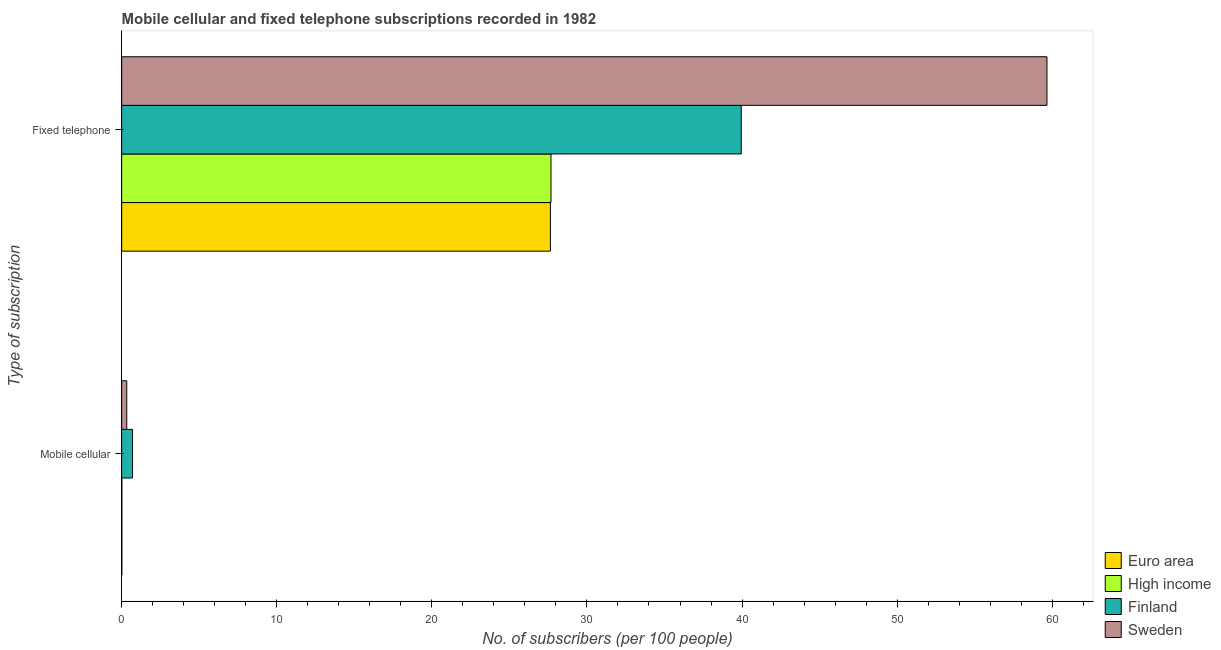How many different coloured bars are there?
Offer a terse response. 4. How many groups of bars are there?
Keep it short and to the point. 2. Are the number of bars per tick equal to the number of legend labels?
Your answer should be compact. Yes. How many bars are there on the 1st tick from the top?
Keep it short and to the point. 4. What is the label of the 2nd group of bars from the top?
Make the answer very short. Mobile cellular. What is the number of fixed telephone subscribers in Sweden?
Keep it short and to the point. 59.66. Across all countries, what is the maximum number of mobile cellular subscribers?
Make the answer very short. 0.7. Across all countries, what is the minimum number of fixed telephone subscribers?
Provide a succinct answer. 27.64. In which country was the number of fixed telephone subscribers maximum?
Your response must be concise. Sweden. What is the total number of mobile cellular subscribers in the graph?
Offer a very short reply. 1.05. What is the difference between the number of fixed telephone subscribers in Sweden and that in High income?
Your response must be concise. 31.98. What is the difference between the number of mobile cellular subscribers in Sweden and the number of fixed telephone subscribers in Euro area?
Make the answer very short. -27.32. What is the average number of mobile cellular subscribers per country?
Give a very brief answer. 0.26. What is the difference between the number of mobile cellular subscribers and number of fixed telephone subscribers in Euro area?
Make the answer very short. -27.63. What is the ratio of the number of fixed telephone subscribers in High income to that in Euro area?
Keep it short and to the point. 1. What does the 4th bar from the bottom in Mobile cellular represents?
Your response must be concise. Sweden. Are all the bars in the graph horizontal?
Your answer should be compact. Yes. How many countries are there in the graph?
Offer a terse response. 4. What is the difference between two consecutive major ticks on the X-axis?
Offer a terse response. 10. Are the values on the major ticks of X-axis written in scientific E-notation?
Ensure brevity in your answer.  No. Does the graph contain grids?
Ensure brevity in your answer.  No. How many legend labels are there?
Your answer should be compact. 4. What is the title of the graph?
Provide a succinct answer. Mobile cellular and fixed telephone subscriptions recorded in 1982. What is the label or title of the X-axis?
Make the answer very short. No. of subscribers (per 100 people). What is the label or title of the Y-axis?
Your answer should be compact. Type of subscription. What is the No. of subscribers (per 100 people) in Euro area in Mobile cellular?
Offer a very short reply. 0.01. What is the No. of subscribers (per 100 people) of High income in Mobile cellular?
Your answer should be very brief. 0.01. What is the No. of subscribers (per 100 people) of Finland in Mobile cellular?
Make the answer very short. 0.7. What is the No. of subscribers (per 100 people) of Sweden in Mobile cellular?
Your answer should be very brief. 0.33. What is the No. of subscribers (per 100 people) in Euro area in Fixed telephone?
Your response must be concise. 27.64. What is the No. of subscribers (per 100 people) of High income in Fixed telephone?
Keep it short and to the point. 27.68. What is the No. of subscribers (per 100 people) in Finland in Fixed telephone?
Provide a short and direct response. 39.95. What is the No. of subscribers (per 100 people) of Sweden in Fixed telephone?
Your response must be concise. 59.66. Across all Type of subscription, what is the maximum No. of subscribers (per 100 people) of Euro area?
Provide a short and direct response. 27.64. Across all Type of subscription, what is the maximum No. of subscribers (per 100 people) of High income?
Your answer should be compact. 27.68. Across all Type of subscription, what is the maximum No. of subscribers (per 100 people) of Finland?
Provide a short and direct response. 39.95. Across all Type of subscription, what is the maximum No. of subscribers (per 100 people) of Sweden?
Make the answer very short. 59.66. Across all Type of subscription, what is the minimum No. of subscribers (per 100 people) in Euro area?
Ensure brevity in your answer.  0.01. Across all Type of subscription, what is the minimum No. of subscribers (per 100 people) in High income?
Offer a very short reply. 0.01. Across all Type of subscription, what is the minimum No. of subscribers (per 100 people) of Finland?
Provide a succinct answer. 0.7. Across all Type of subscription, what is the minimum No. of subscribers (per 100 people) of Sweden?
Offer a terse response. 0.33. What is the total No. of subscribers (per 100 people) of Euro area in the graph?
Make the answer very short. 27.66. What is the total No. of subscribers (per 100 people) of High income in the graph?
Your answer should be very brief. 27.69. What is the total No. of subscribers (per 100 people) of Finland in the graph?
Offer a very short reply. 40.65. What is the total No. of subscribers (per 100 people) in Sweden in the graph?
Keep it short and to the point. 59.99. What is the difference between the No. of subscribers (per 100 people) of Euro area in Mobile cellular and that in Fixed telephone?
Offer a terse response. -27.63. What is the difference between the No. of subscribers (per 100 people) of High income in Mobile cellular and that in Fixed telephone?
Offer a terse response. -27.67. What is the difference between the No. of subscribers (per 100 people) in Finland in Mobile cellular and that in Fixed telephone?
Your answer should be compact. -39.25. What is the difference between the No. of subscribers (per 100 people) of Sweden in Mobile cellular and that in Fixed telephone?
Provide a succinct answer. -59.33. What is the difference between the No. of subscribers (per 100 people) in Euro area in Mobile cellular and the No. of subscribers (per 100 people) in High income in Fixed telephone?
Provide a short and direct response. -27.67. What is the difference between the No. of subscribers (per 100 people) of Euro area in Mobile cellular and the No. of subscribers (per 100 people) of Finland in Fixed telephone?
Your response must be concise. -39.94. What is the difference between the No. of subscribers (per 100 people) in Euro area in Mobile cellular and the No. of subscribers (per 100 people) in Sweden in Fixed telephone?
Give a very brief answer. -59.65. What is the difference between the No. of subscribers (per 100 people) in High income in Mobile cellular and the No. of subscribers (per 100 people) in Finland in Fixed telephone?
Your answer should be compact. -39.94. What is the difference between the No. of subscribers (per 100 people) in High income in Mobile cellular and the No. of subscribers (per 100 people) in Sweden in Fixed telephone?
Provide a succinct answer. -59.65. What is the difference between the No. of subscribers (per 100 people) of Finland in Mobile cellular and the No. of subscribers (per 100 people) of Sweden in Fixed telephone?
Offer a very short reply. -58.96. What is the average No. of subscribers (per 100 people) of Euro area per Type of subscription?
Your answer should be very brief. 13.83. What is the average No. of subscribers (per 100 people) in High income per Type of subscription?
Ensure brevity in your answer.  13.85. What is the average No. of subscribers (per 100 people) of Finland per Type of subscription?
Offer a terse response. 20.33. What is the average No. of subscribers (per 100 people) in Sweden per Type of subscription?
Ensure brevity in your answer.  29.99. What is the difference between the No. of subscribers (per 100 people) of Euro area and No. of subscribers (per 100 people) of High income in Mobile cellular?
Provide a succinct answer. -0. What is the difference between the No. of subscribers (per 100 people) in Euro area and No. of subscribers (per 100 people) in Finland in Mobile cellular?
Your response must be concise. -0.69. What is the difference between the No. of subscribers (per 100 people) of Euro area and No. of subscribers (per 100 people) of Sweden in Mobile cellular?
Provide a succinct answer. -0.32. What is the difference between the No. of subscribers (per 100 people) in High income and No. of subscribers (per 100 people) in Finland in Mobile cellular?
Keep it short and to the point. -0.69. What is the difference between the No. of subscribers (per 100 people) in High income and No. of subscribers (per 100 people) in Sweden in Mobile cellular?
Make the answer very short. -0.32. What is the difference between the No. of subscribers (per 100 people) of Finland and No. of subscribers (per 100 people) of Sweden in Mobile cellular?
Give a very brief answer. 0.37. What is the difference between the No. of subscribers (per 100 people) in Euro area and No. of subscribers (per 100 people) in High income in Fixed telephone?
Provide a succinct answer. -0.04. What is the difference between the No. of subscribers (per 100 people) in Euro area and No. of subscribers (per 100 people) in Finland in Fixed telephone?
Offer a very short reply. -12.3. What is the difference between the No. of subscribers (per 100 people) in Euro area and No. of subscribers (per 100 people) in Sweden in Fixed telephone?
Your answer should be very brief. -32.02. What is the difference between the No. of subscribers (per 100 people) of High income and No. of subscribers (per 100 people) of Finland in Fixed telephone?
Make the answer very short. -12.27. What is the difference between the No. of subscribers (per 100 people) of High income and No. of subscribers (per 100 people) of Sweden in Fixed telephone?
Give a very brief answer. -31.98. What is the difference between the No. of subscribers (per 100 people) in Finland and No. of subscribers (per 100 people) in Sweden in Fixed telephone?
Your response must be concise. -19.71. What is the ratio of the No. of subscribers (per 100 people) in Euro area in Mobile cellular to that in Fixed telephone?
Offer a very short reply. 0. What is the ratio of the No. of subscribers (per 100 people) of Finland in Mobile cellular to that in Fixed telephone?
Your response must be concise. 0.02. What is the ratio of the No. of subscribers (per 100 people) in Sweden in Mobile cellular to that in Fixed telephone?
Offer a very short reply. 0.01. What is the difference between the highest and the second highest No. of subscribers (per 100 people) in Euro area?
Give a very brief answer. 27.63. What is the difference between the highest and the second highest No. of subscribers (per 100 people) of High income?
Your response must be concise. 27.67. What is the difference between the highest and the second highest No. of subscribers (per 100 people) of Finland?
Offer a very short reply. 39.25. What is the difference between the highest and the second highest No. of subscribers (per 100 people) of Sweden?
Your answer should be very brief. 59.33. What is the difference between the highest and the lowest No. of subscribers (per 100 people) in Euro area?
Your response must be concise. 27.63. What is the difference between the highest and the lowest No. of subscribers (per 100 people) in High income?
Provide a succinct answer. 27.67. What is the difference between the highest and the lowest No. of subscribers (per 100 people) in Finland?
Give a very brief answer. 39.25. What is the difference between the highest and the lowest No. of subscribers (per 100 people) of Sweden?
Ensure brevity in your answer.  59.33. 